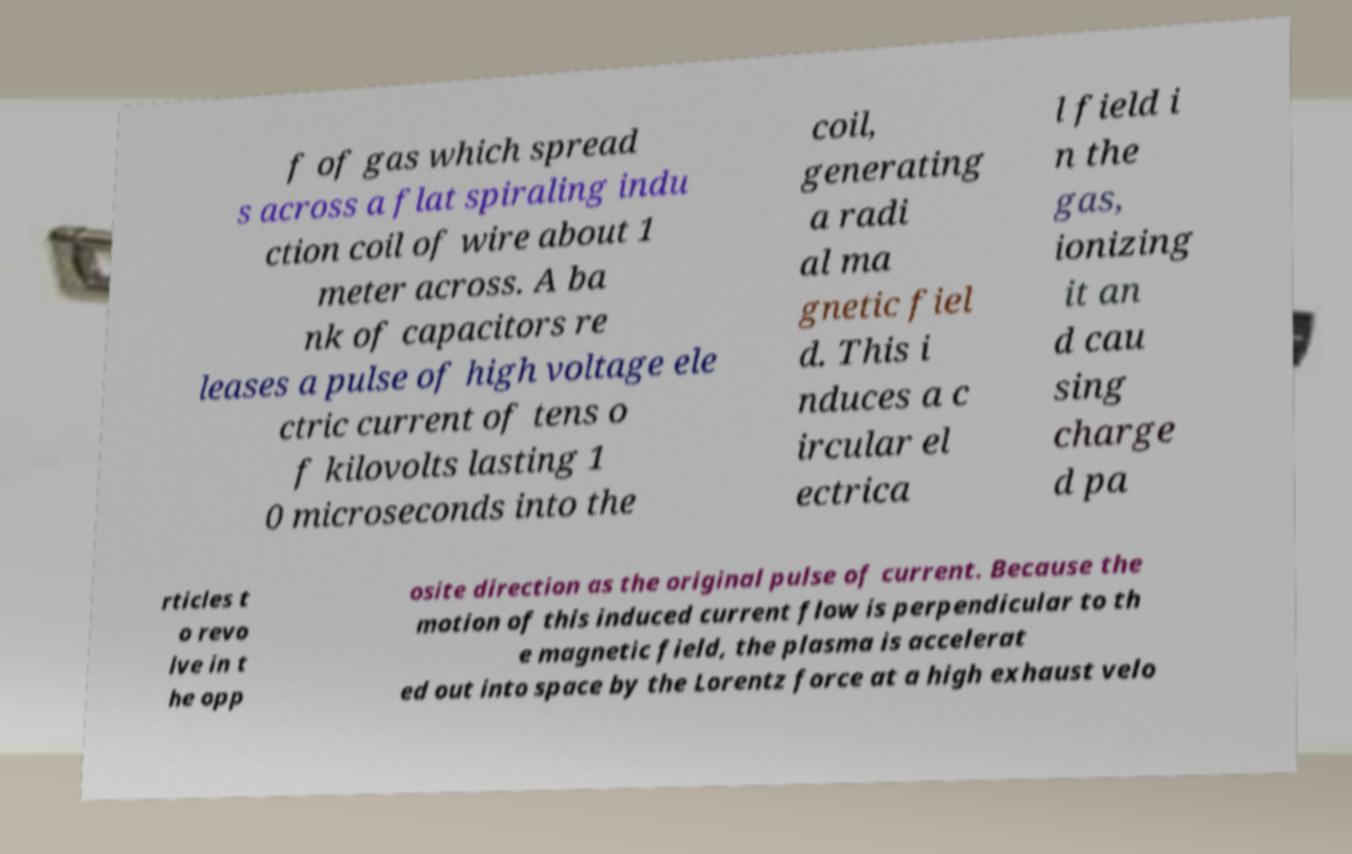Could you assist in decoding the text presented in this image and type it out clearly? f of gas which spread s across a flat spiraling indu ction coil of wire about 1 meter across. A ba nk of capacitors re leases a pulse of high voltage ele ctric current of tens o f kilovolts lasting 1 0 microseconds into the coil, generating a radi al ma gnetic fiel d. This i nduces a c ircular el ectrica l field i n the gas, ionizing it an d cau sing charge d pa rticles t o revo lve in t he opp osite direction as the original pulse of current. Because the motion of this induced current flow is perpendicular to th e magnetic field, the plasma is accelerat ed out into space by the Lorentz force at a high exhaust velo 